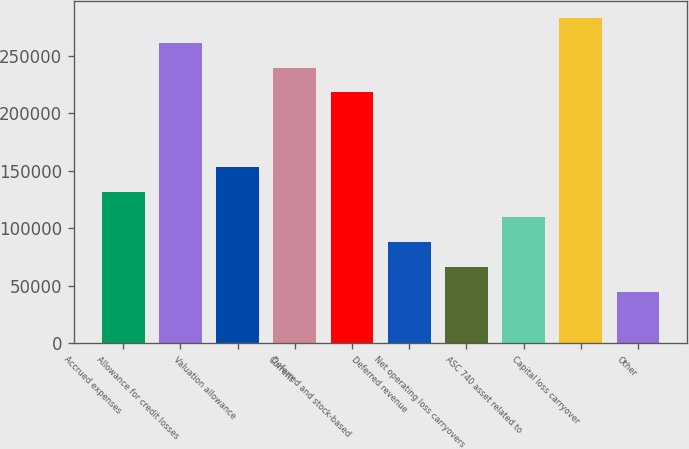<chart> <loc_0><loc_0><loc_500><loc_500><bar_chart><fcel>Accrued expenses<fcel>Allowance for credit losses<fcel>Valuation allowance<fcel>Current<fcel>Deferred and stock-based<fcel>Deferred revenue<fcel>Net operating loss carryovers<fcel>ASC 740 asset related to<fcel>Capital loss carryover<fcel>Other<nl><fcel>131470<fcel>261266<fcel>153103<fcel>239634<fcel>218001<fcel>88204.8<fcel>66572.1<fcel>109838<fcel>282899<fcel>44939.4<nl></chart> 